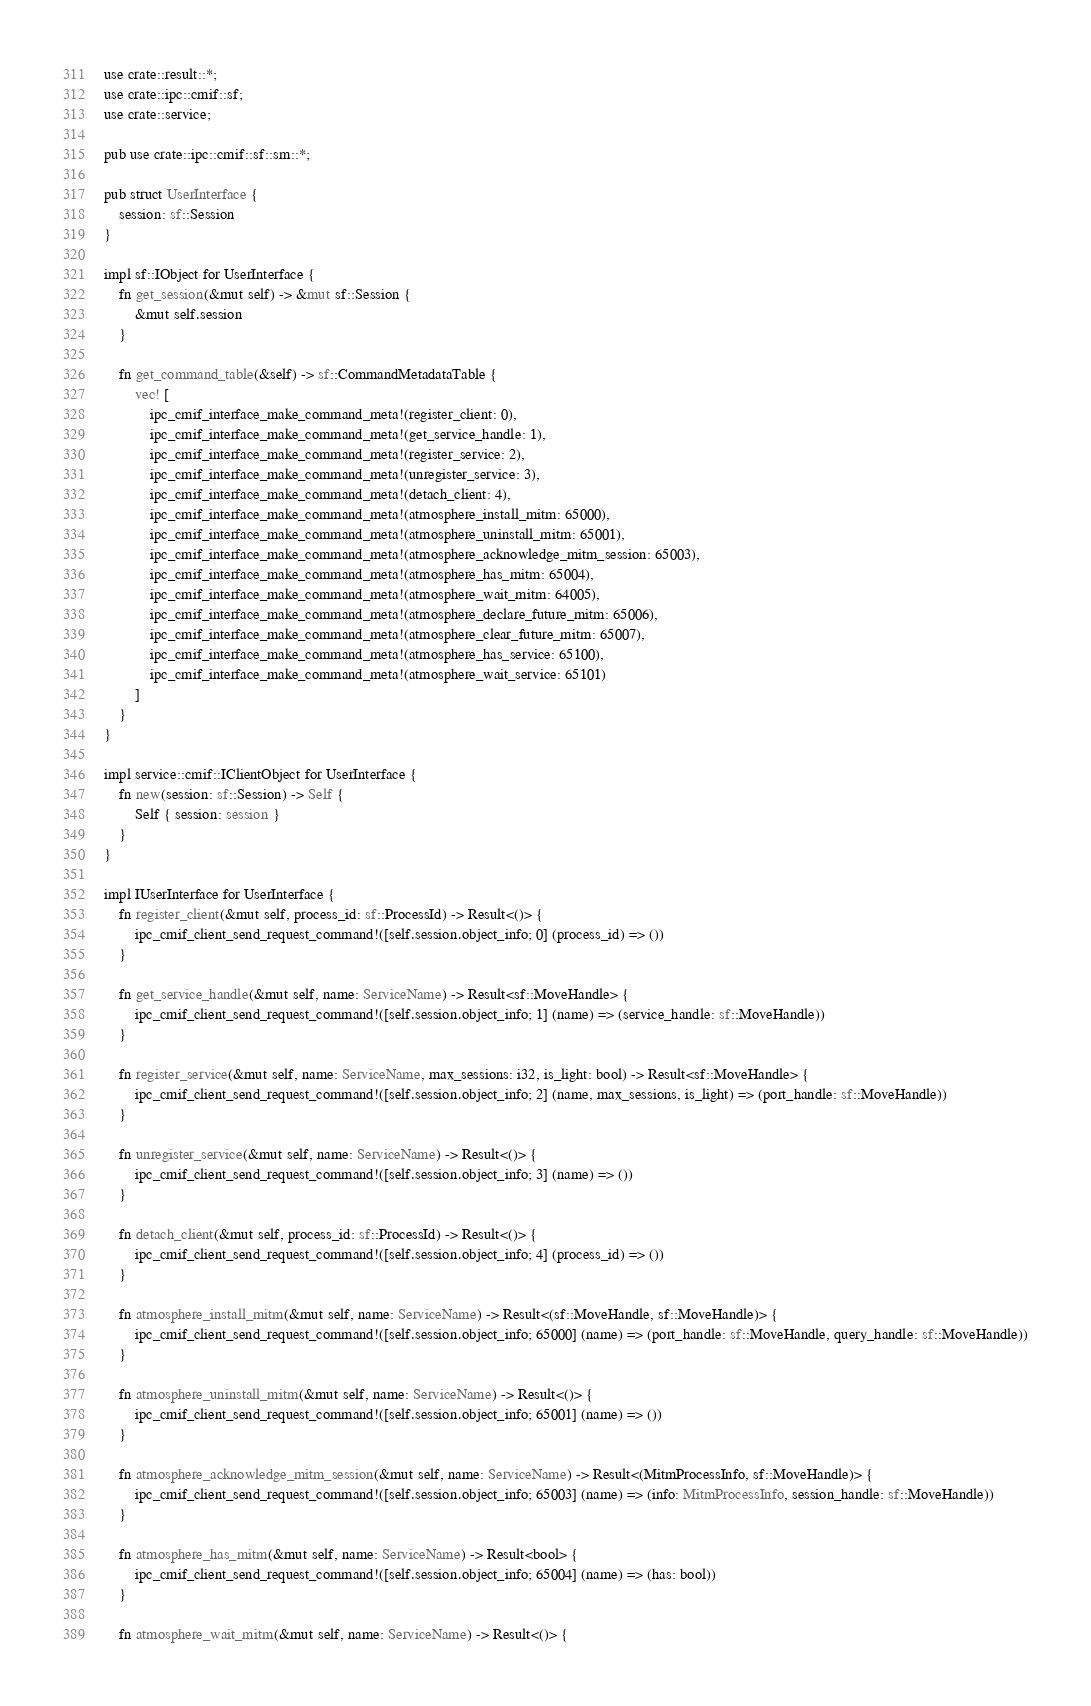Convert code to text. <code><loc_0><loc_0><loc_500><loc_500><_Rust_>use crate::result::*;
use crate::ipc::cmif::sf;
use crate::service;

pub use crate::ipc::cmif::sf::sm::*;

pub struct UserInterface {
    session: sf::Session
}

impl sf::IObject for UserInterface {
    fn get_session(&mut self) -> &mut sf::Session {
        &mut self.session
    }

    fn get_command_table(&self) -> sf::CommandMetadataTable {
        vec! [
            ipc_cmif_interface_make_command_meta!(register_client: 0),
            ipc_cmif_interface_make_command_meta!(get_service_handle: 1),
            ipc_cmif_interface_make_command_meta!(register_service: 2),
            ipc_cmif_interface_make_command_meta!(unregister_service: 3),
            ipc_cmif_interface_make_command_meta!(detach_client: 4),
            ipc_cmif_interface_make_command_meta!(atmosphere_install_mitm: 65000),
            ipc_cmif_interface_make_command_meta!(atmosphere_uninstall_mitm: 65001),
            ipc_cmif_interface_make_command_meta!(atmosphere_acknowledge_mitm_session: 65003),
            ipc_cmif_interface_make_command_meta!(atmosphere_has_mitm: 65004),
            ipc_cmif_interface_make_command_meta!(atmosphere_wait_mitm: 64005),
            ipc_cmif_interface_make_command_meta!(atmosphere_declare_future_mitm: 65006),
            ipc_cmif_interface_make_command_meta!(atmosphere_clear_future_mitm: 65007),
            ipc_cmif_interface_make_command_meta!(atmosphere_has_service: 65100),
            ipc_cmif_interface_make_command_meta!(atmosphere_wait_service: 65101)
        ]
    }
}

impl service::cmif::IClientObject for UserInterface {
    fn new(session: sf::Session) -> Self {
        Self { session: session }
    }
}

impl IUserInterface for UserInterface {
    fn register_client(&mut self, process_id: sf::ProcessId) -> Result<()> {
        ipc_cmif_client_send_request_command!([self.session.object_info; 0] (process_id) => ())
    }

    fn get_service_handle(&mut self, name: ServiceName) -> Result<sf::MoveHandle> {
        ipc_cmif_client_send_request_command!([self.session.object_info; 1] (name) => (service_handle: sf::MoveHandle))
    }

    fn register_service(&mut self, name: ServiceName, max_sessions: i32, is_light: bool) -> Result<sf::MoveHandle> {
        ipc_cmif_client_send_request_command!([self.session.object_info; 2] (name, max_sessions, is_light) => (port_handle: sf::MoveHandle))
    }

    fn unregister_service(&mut self, name: ServiceName) -> Result<()> {
        ipc_cmif_client_send_request_command!([self.session.object_info; 3] (name) => ())
    }

    fn detach_client(&mut self, process_id: sf::ProcessId) -> Result<()> {
        ipc_cmif_client_send_request_command!([self.session.object_info; 4] (process_id) => ())
    }

    fn atmosphere_install_mitm(&mut self, name: ServiceName) -> Result<(sf::MoveHandle, sf::MoveHandle)> {
        ipc_cmif_client_send_request_command!([self.session.object_info; 65000] (name) => (port_handle: sf::MoveHandle, query_handle: sf::MoveHandle))
    }

    fn atmosphere_uninstall_mitm(&mut self, name: ServiceName) -> Result<()> {
        ipc_cmif_client_send_request_command!([self.session.object_info; 65001] (name) => ())
    }
    
    fn atmosphere_acknowledge_mitm_session(&mut self, name: ServiceName) -> Result<(MitmProcessInfo, sf::MoveHandle)> {
        ipc_cmif_client_send_request_command!([self.session.object_info; 65003] (name) => (info: MitmProcessInfo, session_handle: sf::MoveHandle))
    }

    fn atmosphere_has_mitm(&mut self, name: ServiceName) -> Result<bool> {
        ipc_cmif_client_send_request_command!([self.session.object_info; 65004] (name) => (has: bool))
    }

    fn atmosphere_wait_mitm(&mut self, name: ServiceName) -> Result<()> {</code> 